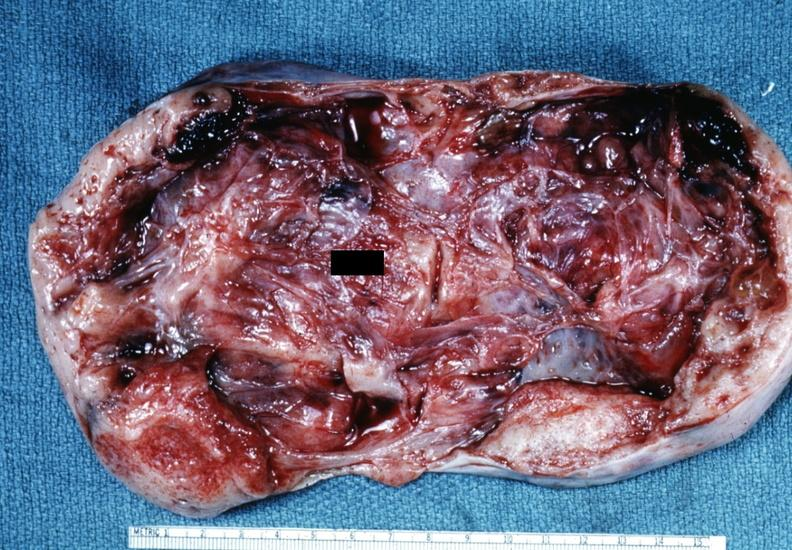what is present?
Answer the question using a single word or phrase. Female reproductive 